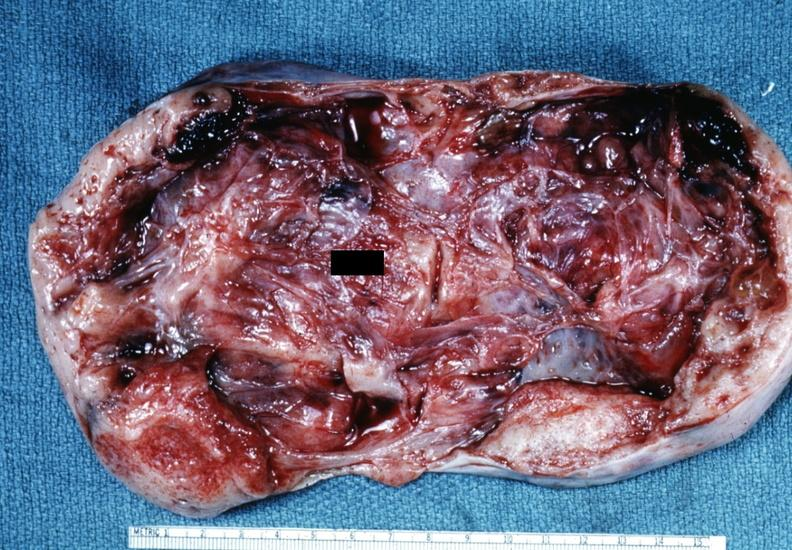what is present?
Answer the question using a single word or phrase. Female reproductive 